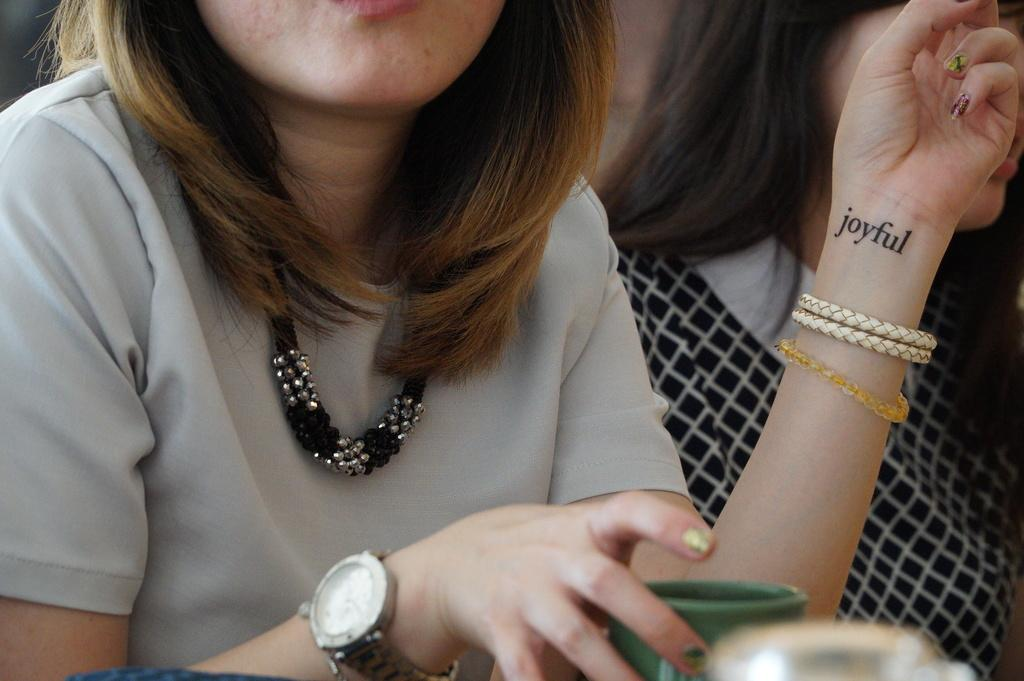<image>
Summarize the visual content of the image. a lady with joyful tattooed on her forearm 